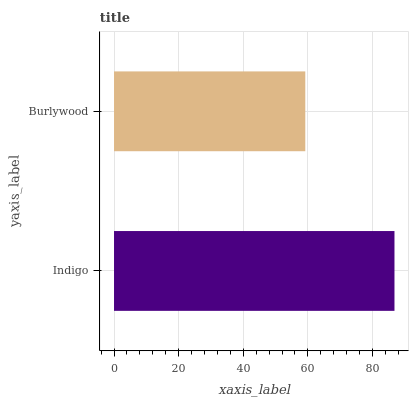Is Burlywood the minimum?
Answer yes or no. Yes. Is Indigo the maximum?
Answer yes or no. Yes. Is Burlywood the maximum?
Answer yes or no. No. Is Indigo greater than Burlywood?
Answer yes or no. Yes. Is Burlywood less than Indigo?
Answer yes or no. Yes. Is Burlywood greater than Indigo?
Answer yes or no. No. Is Indigo less than Burlywood?
Answer yes or no. No. Is Indigo the high median?
Answer yes or no. Yes. Is Burlywood the low median?
Answer yes or no. Yes. Is Burlywood the high median?
Answer yes or no. No. Is Indigo the low median?
Answer yes or no. No. 